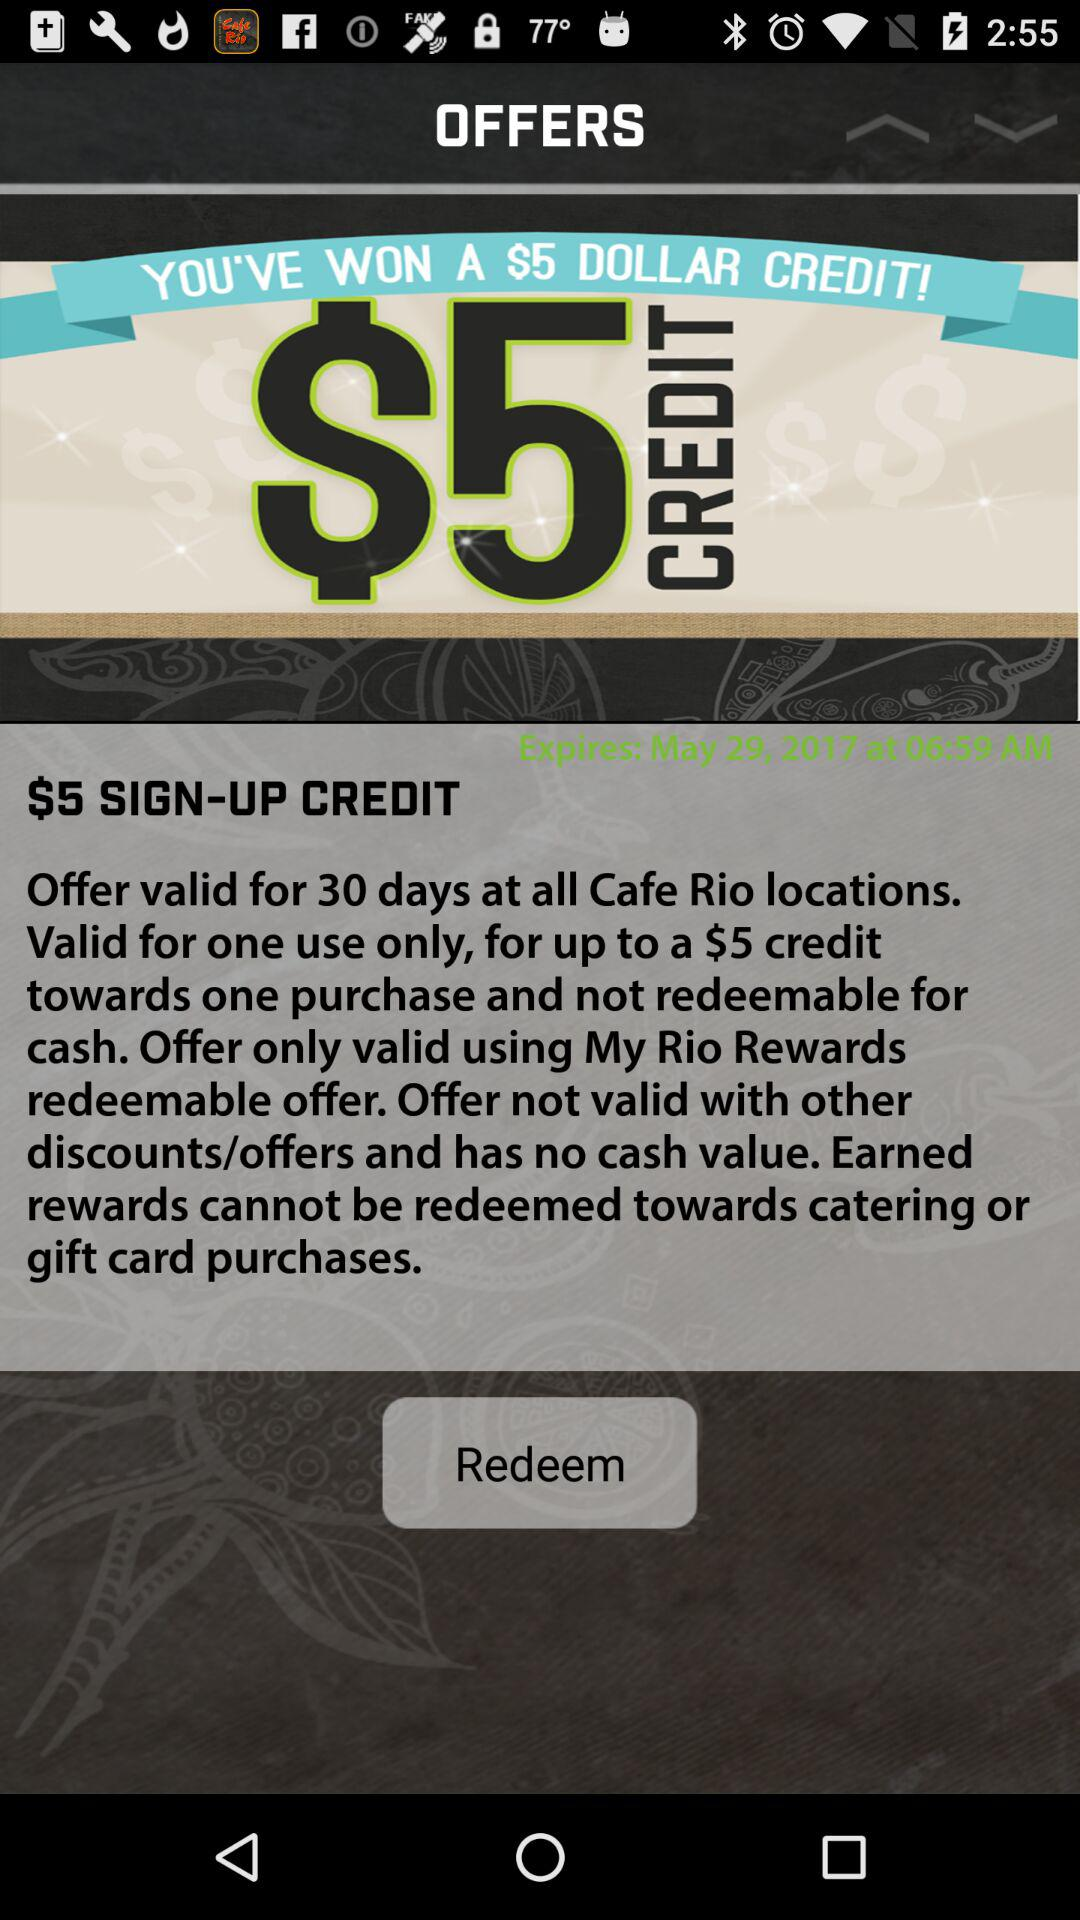What is the expiration date of the offer?
Answer the question using a single word or phrase. May 29, 2017 at 06:59 AM 